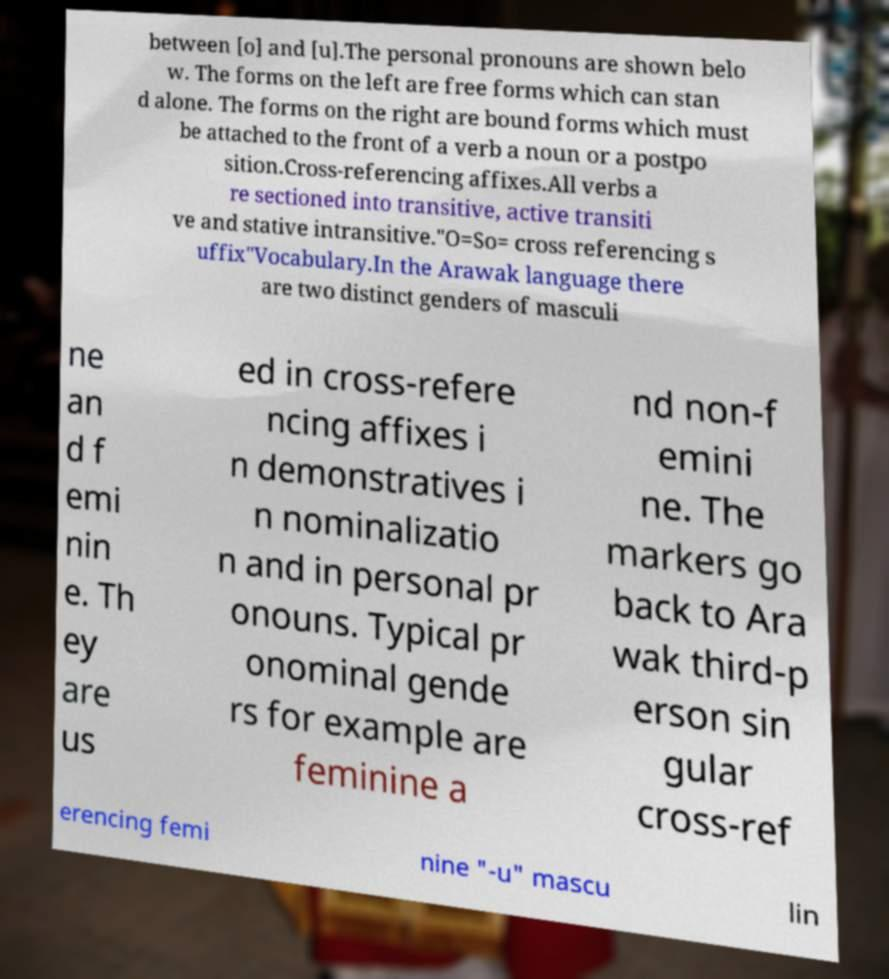Could you extract and type out the text from this image? between [o] and [u].The personal pronouns are shown belo w. The forms on the left are free forms which can stan d alone. The forms on the right are bound forms which must be attached to the front of a verb a noun or a postpo sition.Cross-referencing affixes.All verbs a re sectioned into transitive, active transiti ve and stative intransitive."O=So= cross referencing s uffix"Vocabulary.In the Arawak language there are two distinct genders of masculi ne an d f emi nin e. Th ey are us ed in cross-refere ncing affixes i n demonstratives i n nominalizatio n and in personal pr onouns. Typical pr onominal gende rs for example are feminine a nd non-f emini ne. The markers go back to Ara wak third-p erson sin gular cross-ref erencing femi nine "-u" mascu lin 